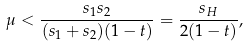Convert formula to latex. <formula><loc_0><loc_0><loc_500><loc_500>\mu < \frac { s _ { 1 } s _ { 2 } } { ( s _ { 1 } + s _ { 2 } ) ( 1 - t ) } = \frac { s _ { H } } { 2 ( 1 - t ) } ,</formula> 